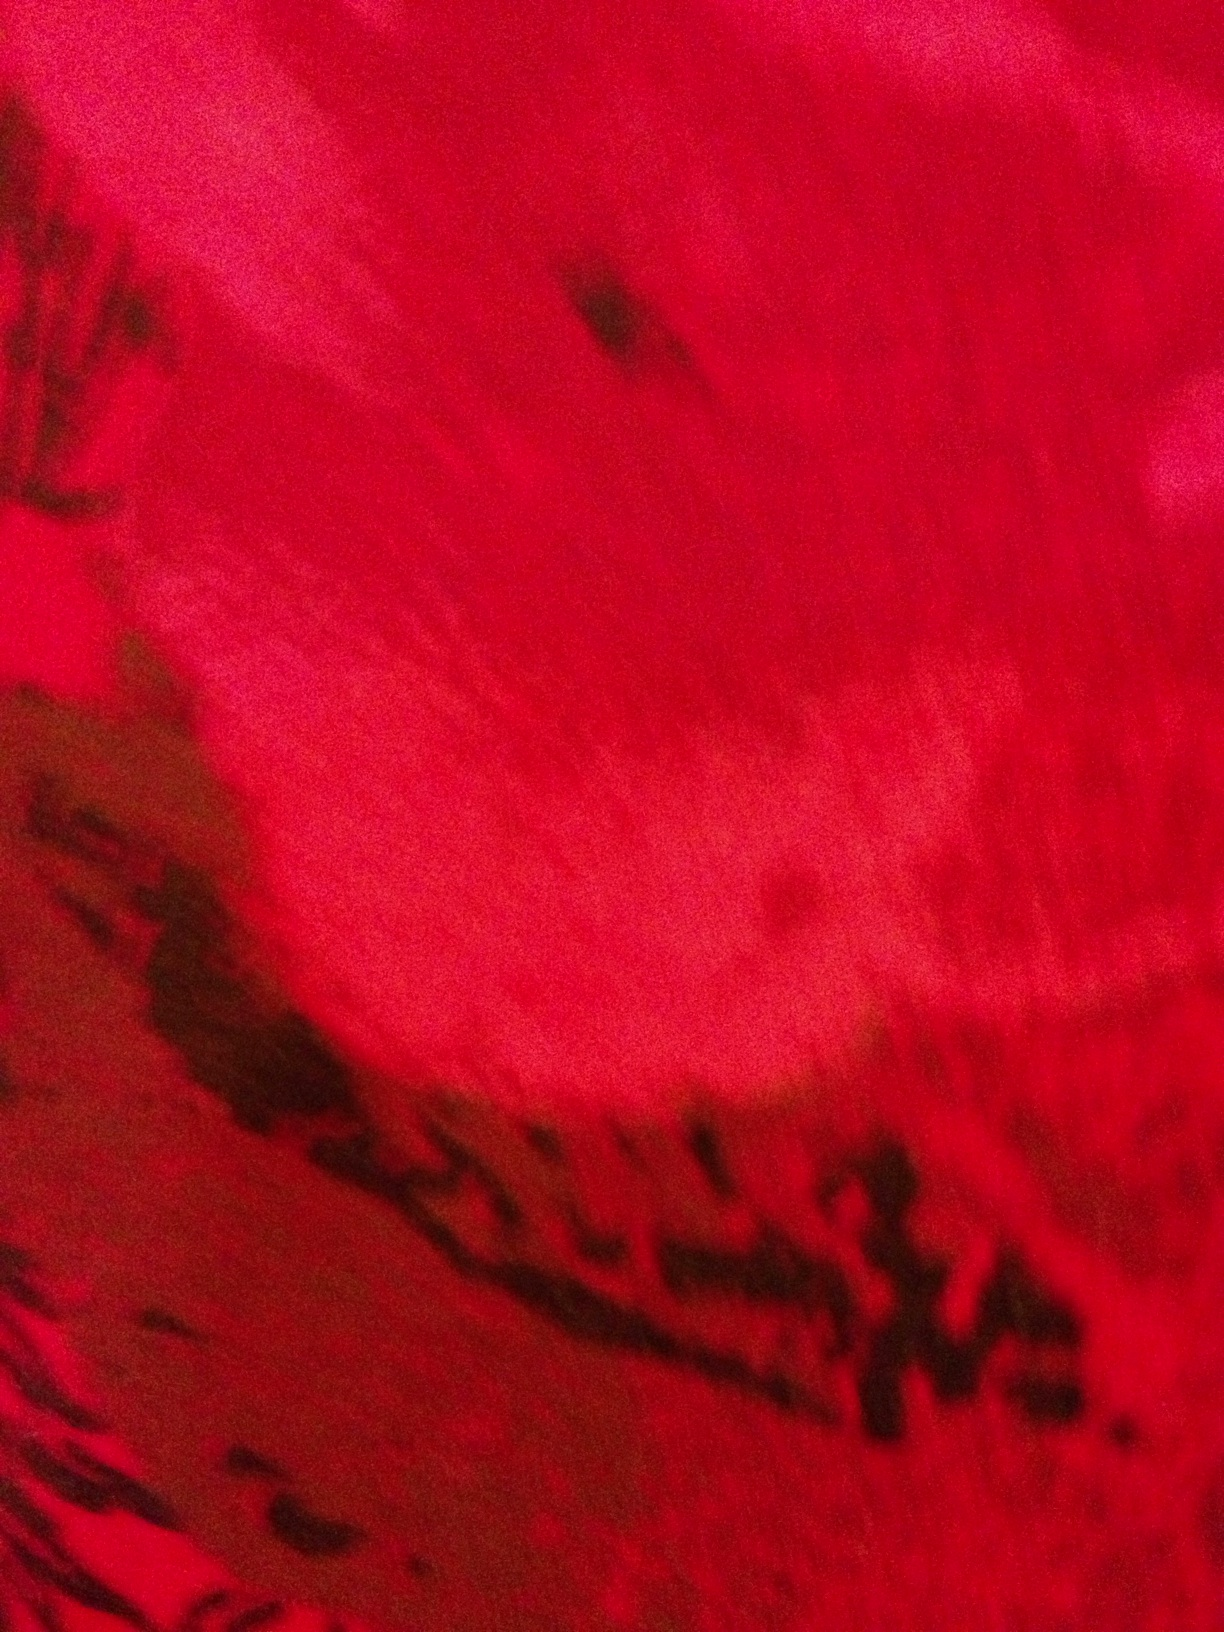What emotions does the color red in this image evoke? The dominant red color in the image can evoke feelings of passion and intensity. It might also be associated with energy and vitality, while the darker tones could add a sense of mystery or foreboding. 